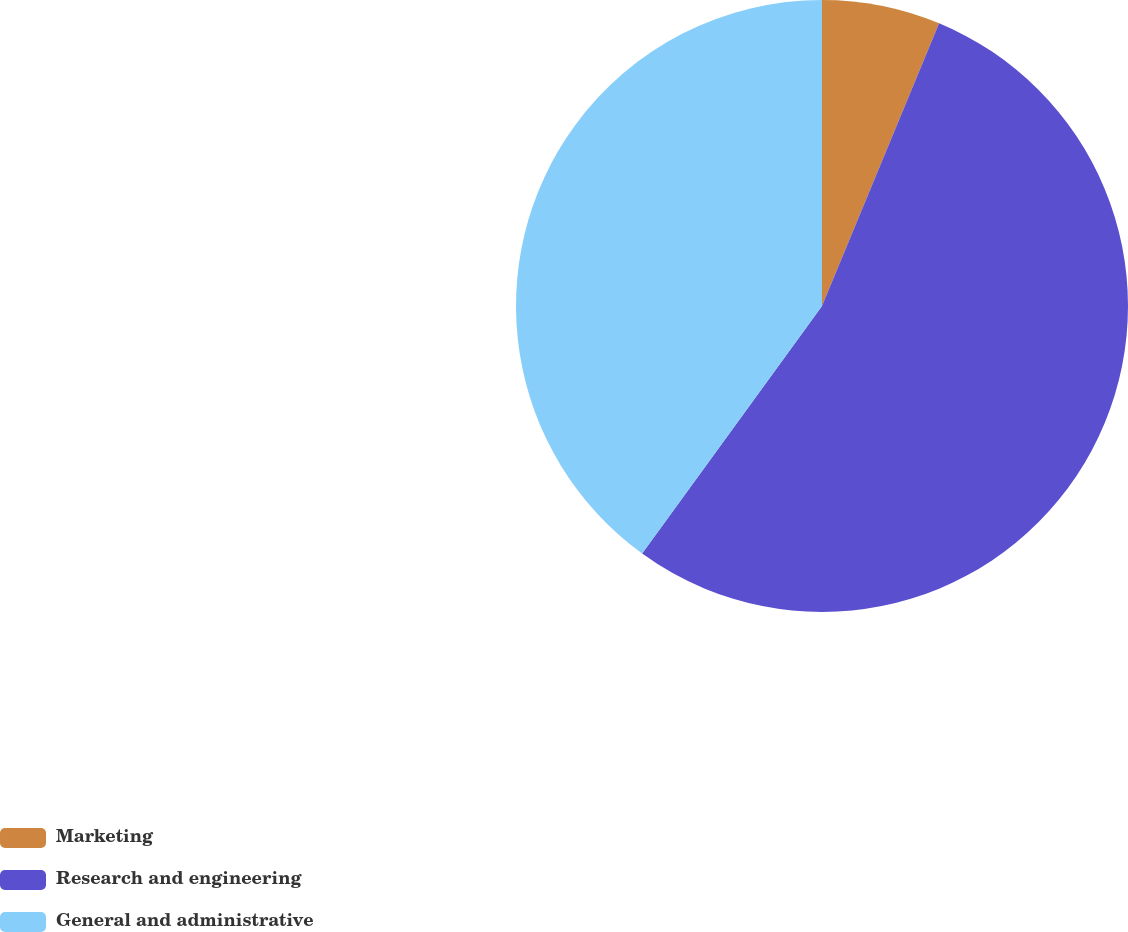<chart> <loc_0><loc_0><loc_500><loc_500><pie_chart><fcel>Marketing<fcel>Research and engineering<fcel>General and administrative<nl><fcel>6.25%<fcel>53.75%<fcel>40.0%<nl></chart> 